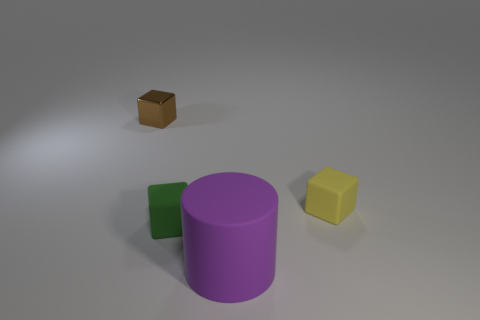Is there anything else that is the same shape as the big rubber thing?
Provide a succinct answer. No. There is a object that is on the left side of the purple object and on the right side of the brown block; what color is it?
Your answer should be compact. Green. There is a cube behind the small yellow cube; what color is it?
Ensure brevity in your answer.  Brown. There is a yellow matte thing to the right of the green rubber thing; are there any tiny green matte blocks behind it?
Provide a short and direct response. No. Are there any large purple objects made of the same material as the small yellow object?
Provide a succinct answer. Yes. What number of large rubber cylinders are there?
Your answer should be compact. 1. There is a cube that is behind the matte object that is right of the matte cylinder; what is it made of?
Your answer should be compact. Metal. There is another tiny block that is made of the same material as the green cube; what color is it?
Ensure brevity in your answer.  Yellow. Does the cube that is right of the green object have the same size as the matte object that is to the left of the large purple rubber cylinder?
Offer a very short reply. Yes. What number of cylinders are yellow things or tiny blue metal objects?
Offer a very short reply. 0. 